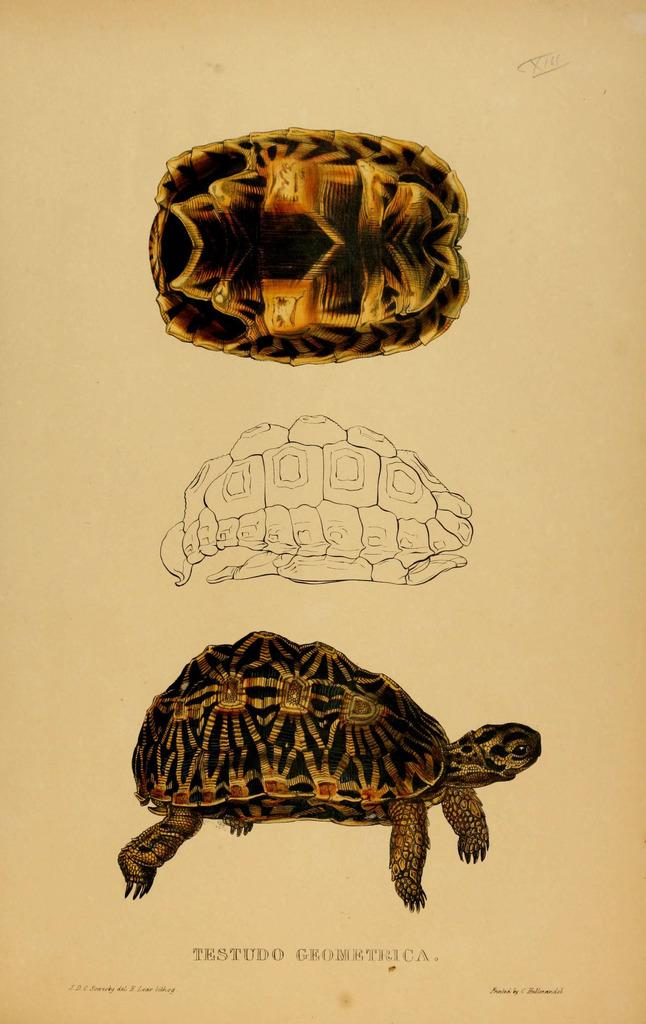What is depicted in the drawing in the image? There is a drawing of a tortoise in the image. What part of the tortoise is visible in the drawing? The tortoise's shell is visible in the drawing. What is the color of the paper on which the drawing is made? The paper is cream-colored. Is there any text present in the image? Yes, there is writing at the bottom of the image. Can you see any trails left by bees in the image? There are no bees or trails visible in the image; it features a drawing of a tortoise on cream-colored paper with writing at the bottom. What type of nerve is shown in the image? There is no nerve depicted in the image; it features a drawing of a tortoise on cream-colored paper with writing at the bottom. 